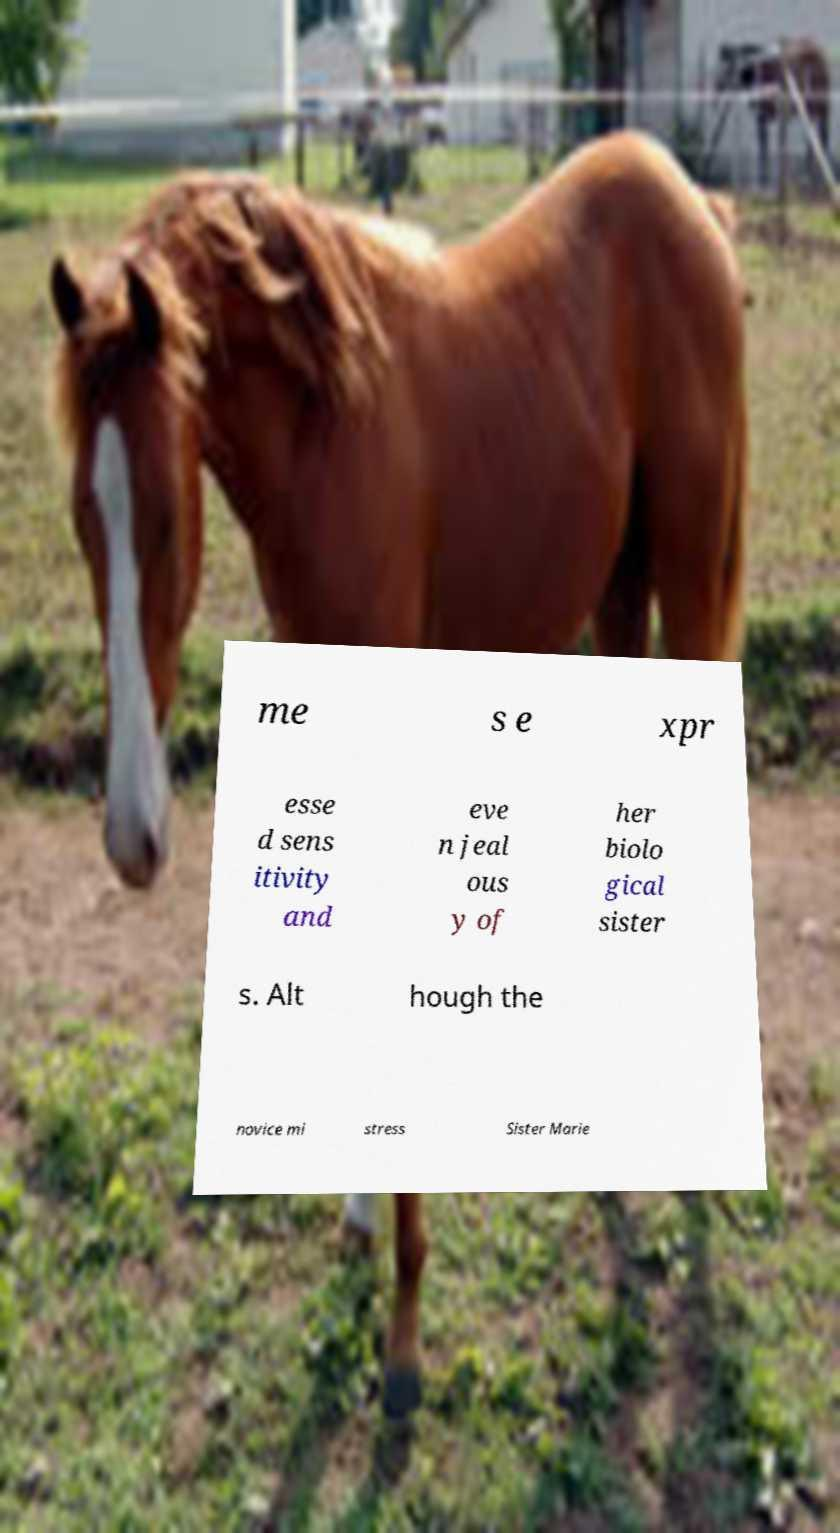There's text embedded in this image that I need extracted. Can you transcribe it verbatim? me s e xpr esse d sens itivity and eve n jeal ous y of her biolo gical sister s. Alt hough the novice mi stress Sister Marie 